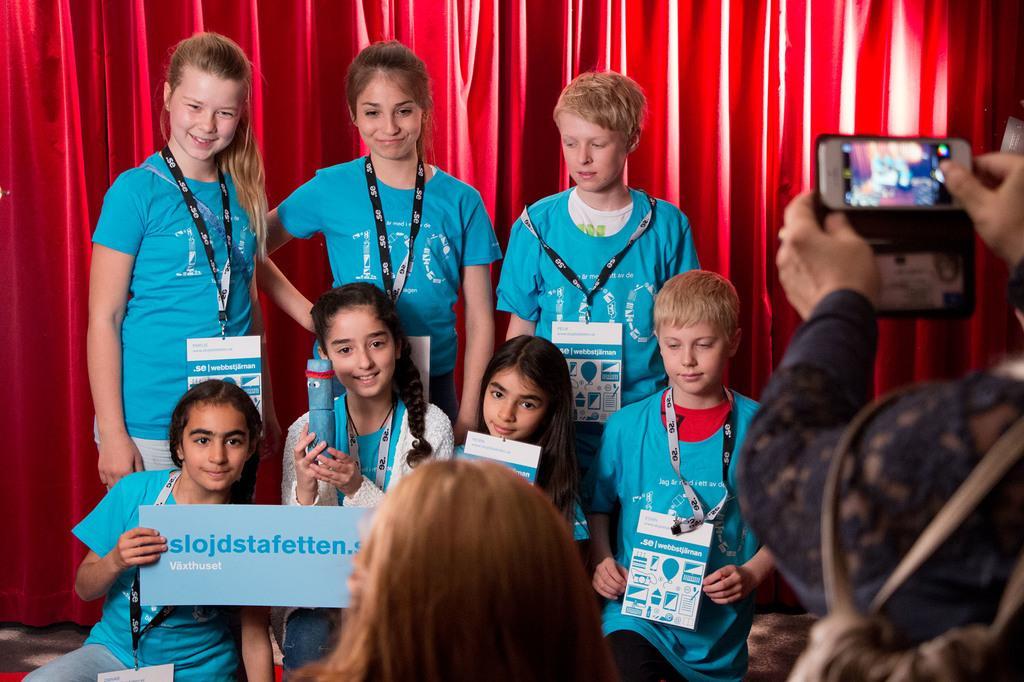Could you give a brief overview of what you see in this image? In this picture there are children in the center of the image, by holding a poster in there hands and there is a lady at the bottom side of the image and there is a person who is taking photo on the right side of the image, there is a red color curtain in the background area of the image. 